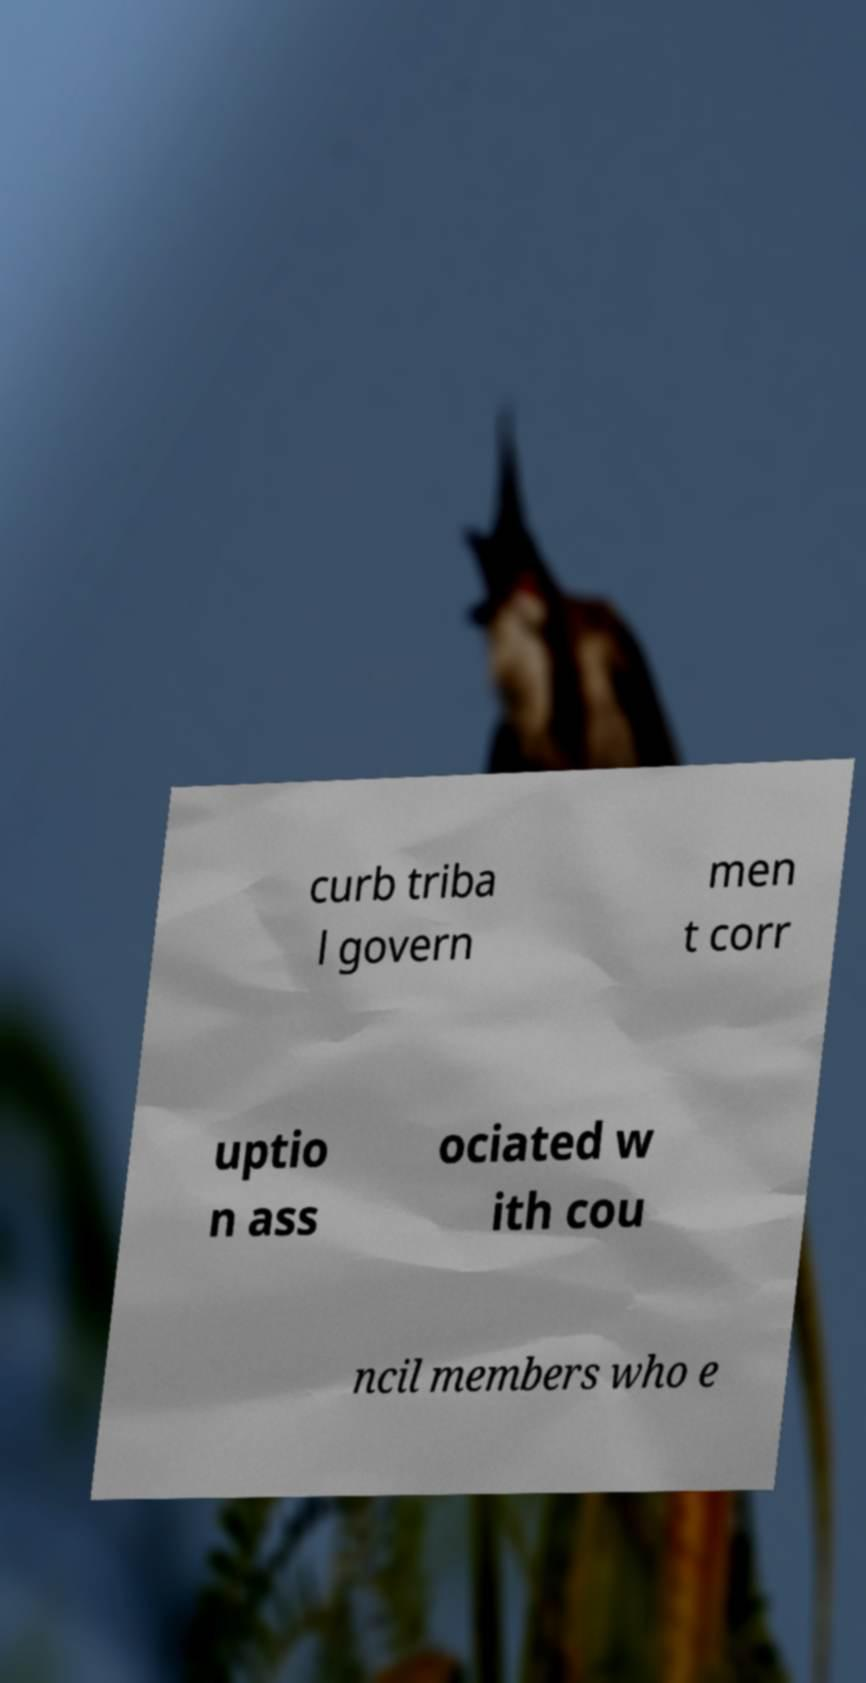Could you assist in decoding the text presented in this image and type it out clearly? curb triba l govern men t corr uptio n ass ociated w ith cou ncil members who e 